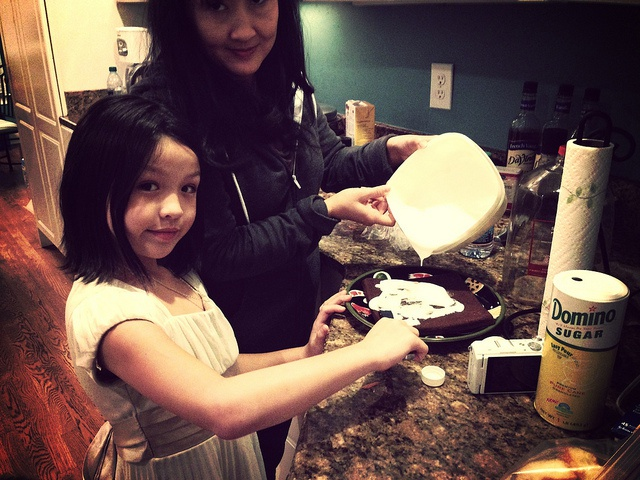Describe the objects in this image and their specific colors. I can see people in orange, black, khaki, brown, and maroon tones, people in orange, black, maroon, gray, and khaki tones, bowl in orange, lightyellow, khaki, and gray tones, bottle in orange, black, brown, and gray tones, and cake in orange, lightyellow, maroon, black, and brown tones in this image. 